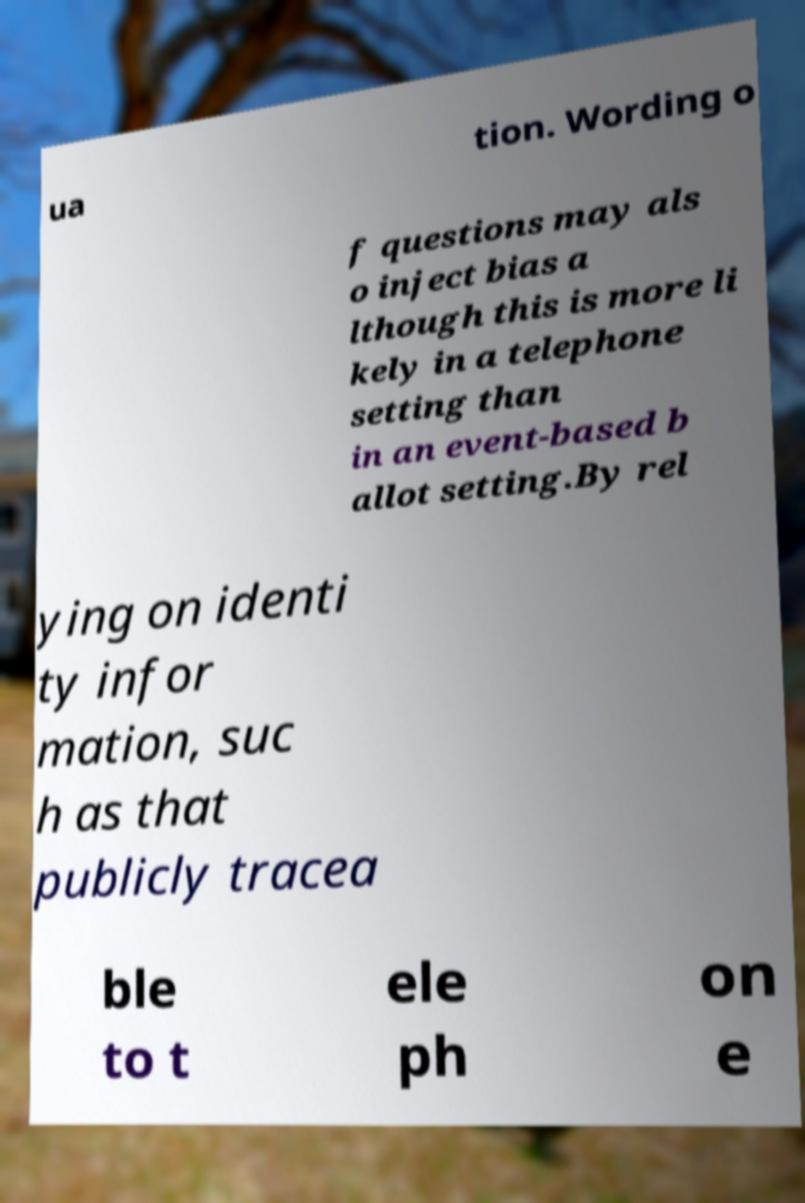Please identify and transcribe the text found in this image. ua tion. Wording o f questions may als o inject bias a lthough this is more li kely in a telephone setting than in an event-based b allot setting.By rel ying on identi ty infor mation, suc h as that publicly tracea ble to t ele ph on e 